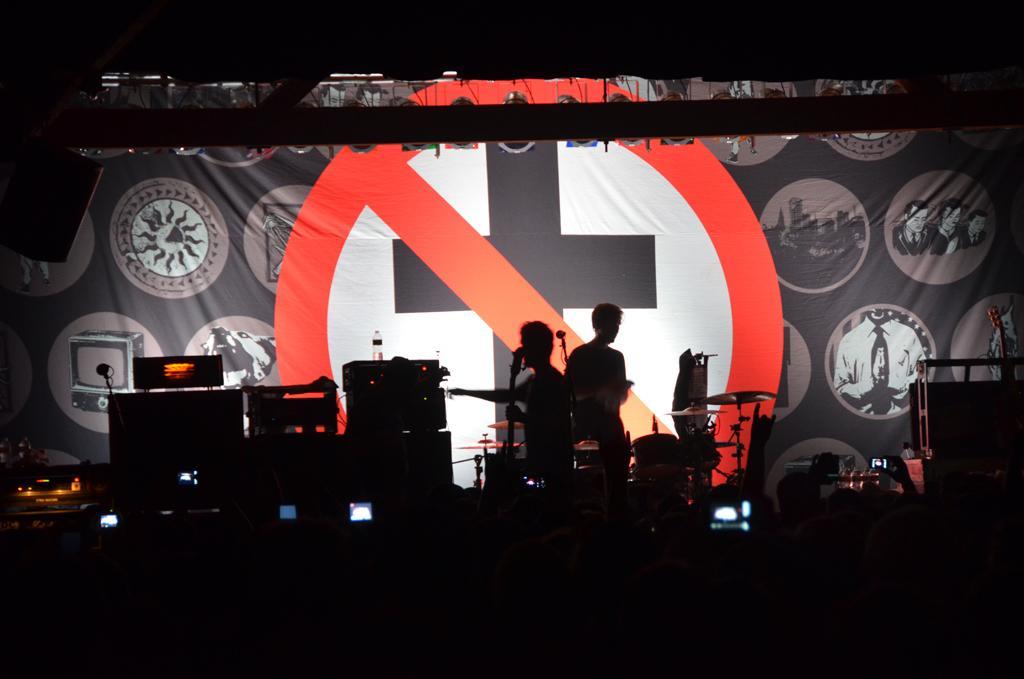How would you summarize this image in a sentence or two? This picture is taken in the dark, where we can see two persons are standing. Here we can see musical instruments, some objects and in the background, we can see the banner. 